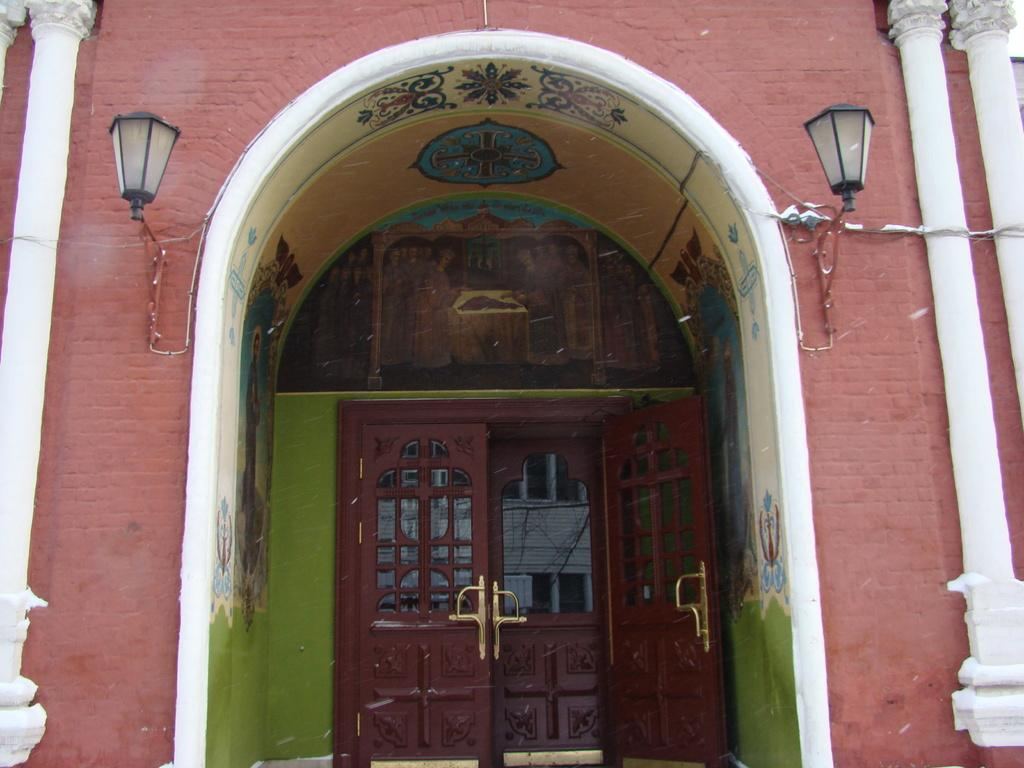What is the main subject of the image? The main subject of the image is the front view of a building. What can be seen on the front of the building? There is a closed wooden door in the image. Are there any additional features near the door? Yes, there are lamps on the wall beside the door. How many bikes are parked in front of the building in the image? There are no bikes visible in the image; it only shows the front view of the building, a closed wooden door, and lamps on the wall. What advice is given by the building in the image? Buildings do not give advice; they are inanimate structures. 